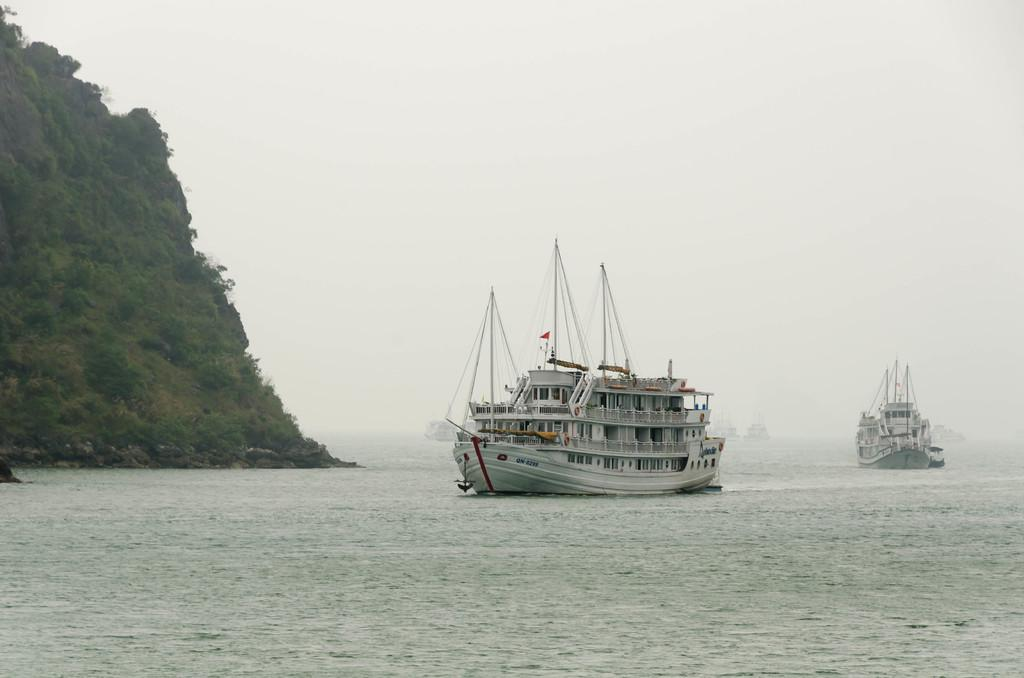What can be seen floating on the water in the image? There are ships floating on the water in the image. What type of landform is on the left side of the image? There is a hill on the left side of the image. What is visible in the background of the image? The sky is visible in the background of the image. What is the price of the pin featured in the image? There is no pin present in the image, so it is not possible to determine its price. 